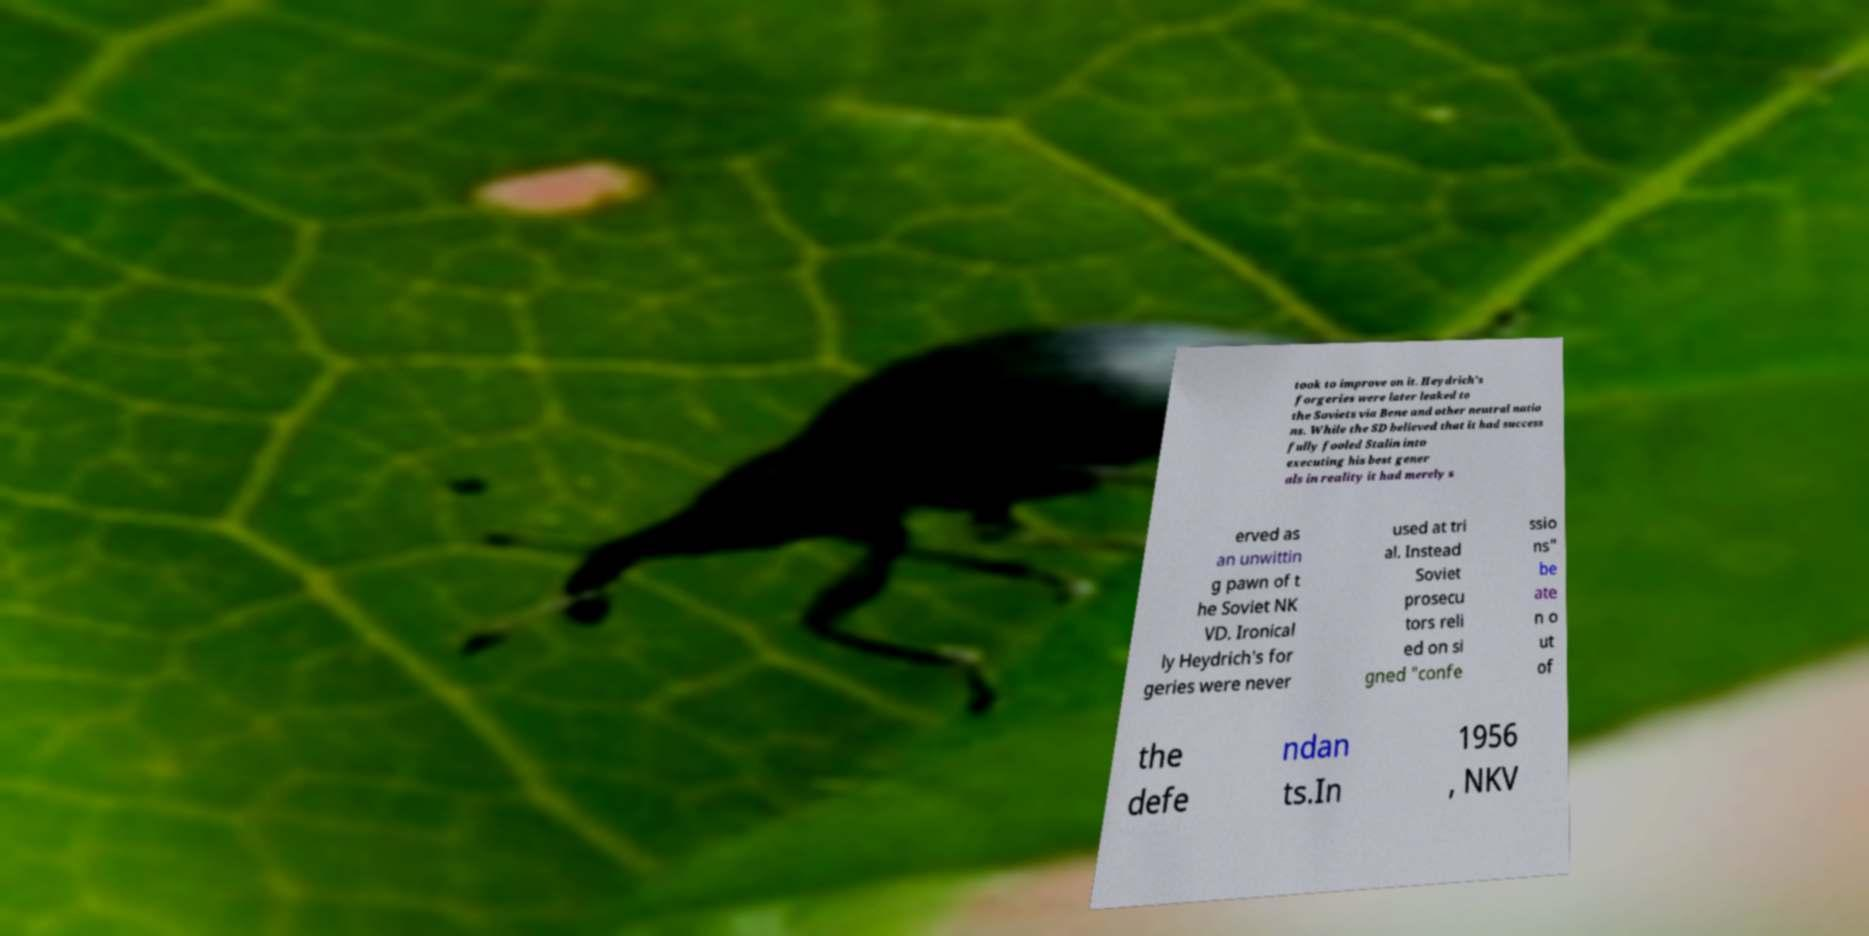Please identify and transcribe the text found in this image. took to improve on it. Heydrich's forgeries were later leaked to the Soviets via Bene and other neutral natio ns. While the SD believed that it had success fully fooled Stalin into executing his best gener als in reality it had merely s erved as an unwittin g pawn of t he Soviet NK VD. Ironical ly Heydrich's for geries were never used at tri al. Instead Soviet prosecu tors reli ed on si gned "confe ssio ns" be ate n o ut of the defe ndan ts.In 1956 , NKV 